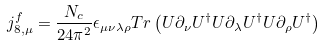Convert formula to latex. <formula><loc_0><loc_0><loc_500><loc_500>j _ { 8 , \mu } ^ { f } = \frac { N _ { c } } { 2 4 \pi ^ { 2 } } \epsilon _ { \mu \nu \lambda \rho } T r \left ( U \partial _ { \nu } U ^ { \dagger } U \partial _ { \lambda } U ^ { \dagger } U \partial _ { \rho } U ^ { \dagger } \right )</formula> 